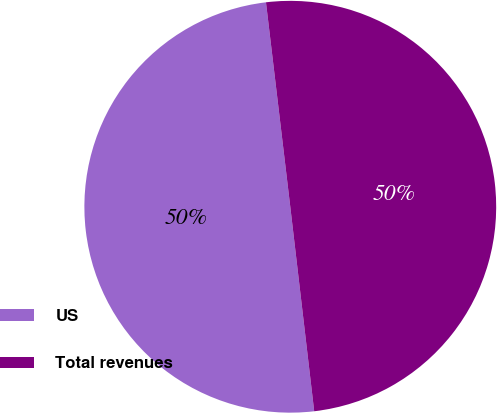Convert chart. <chart><loc_0><loc_0><loc_500><loc_500><pie_chart><fcel>US<fcel>Total revenues<nl><fcel>49.97%<fcel>50.03%<nl></chart> 